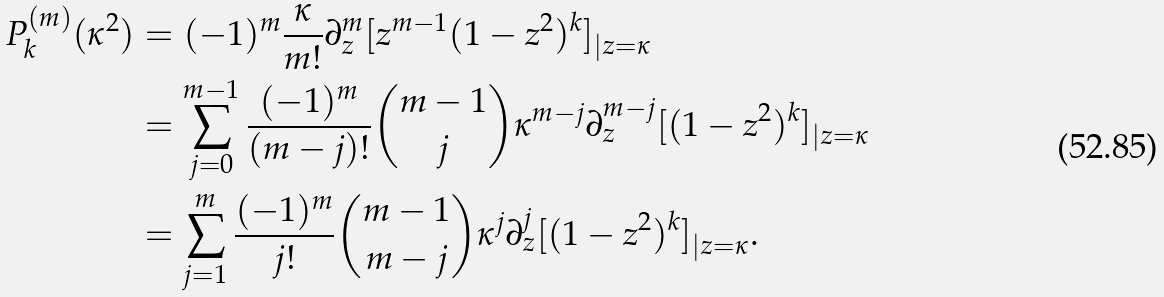Convert formula to latex. <formula><loc_0><loc_0><loc_500><loc_500>P _ { k } ^ { ( m ) } ( \kappa ^ { 2 } ) & = ( - 1 ) ^ { m } \frac { \kappa } { m ! } \partial _ { z } ^ { m } [ z ^ { m - 1 } ( 1 - z ^ { 2 } ) ^ { k } ] _ { | z = \kappa } \\ & = \sum _ { j = 0 } ^ { m - 1 } \frac { ( - 1 ) ^ { m } } { ( m - j ) ! } \binom { m - 1 } { j } \kappa ^ { m - j } \partial _ { z } ^ { m - j } [ ( 1 - z ^ { 2 } ) ^ { k } ] _ { | z = \kappa } \\ & = \sum _ { j = 1 } ^ { m } \frac { ( - 1 ) ^ { m } } { j ! } \binom { m - 1 } { m - j } \kappa ^ { j } \partial _ { z } ^ { j } [ ( 1 - z ^ { 2 } ) ^ { k } ] _ { | z = \kappa } .</formula> 